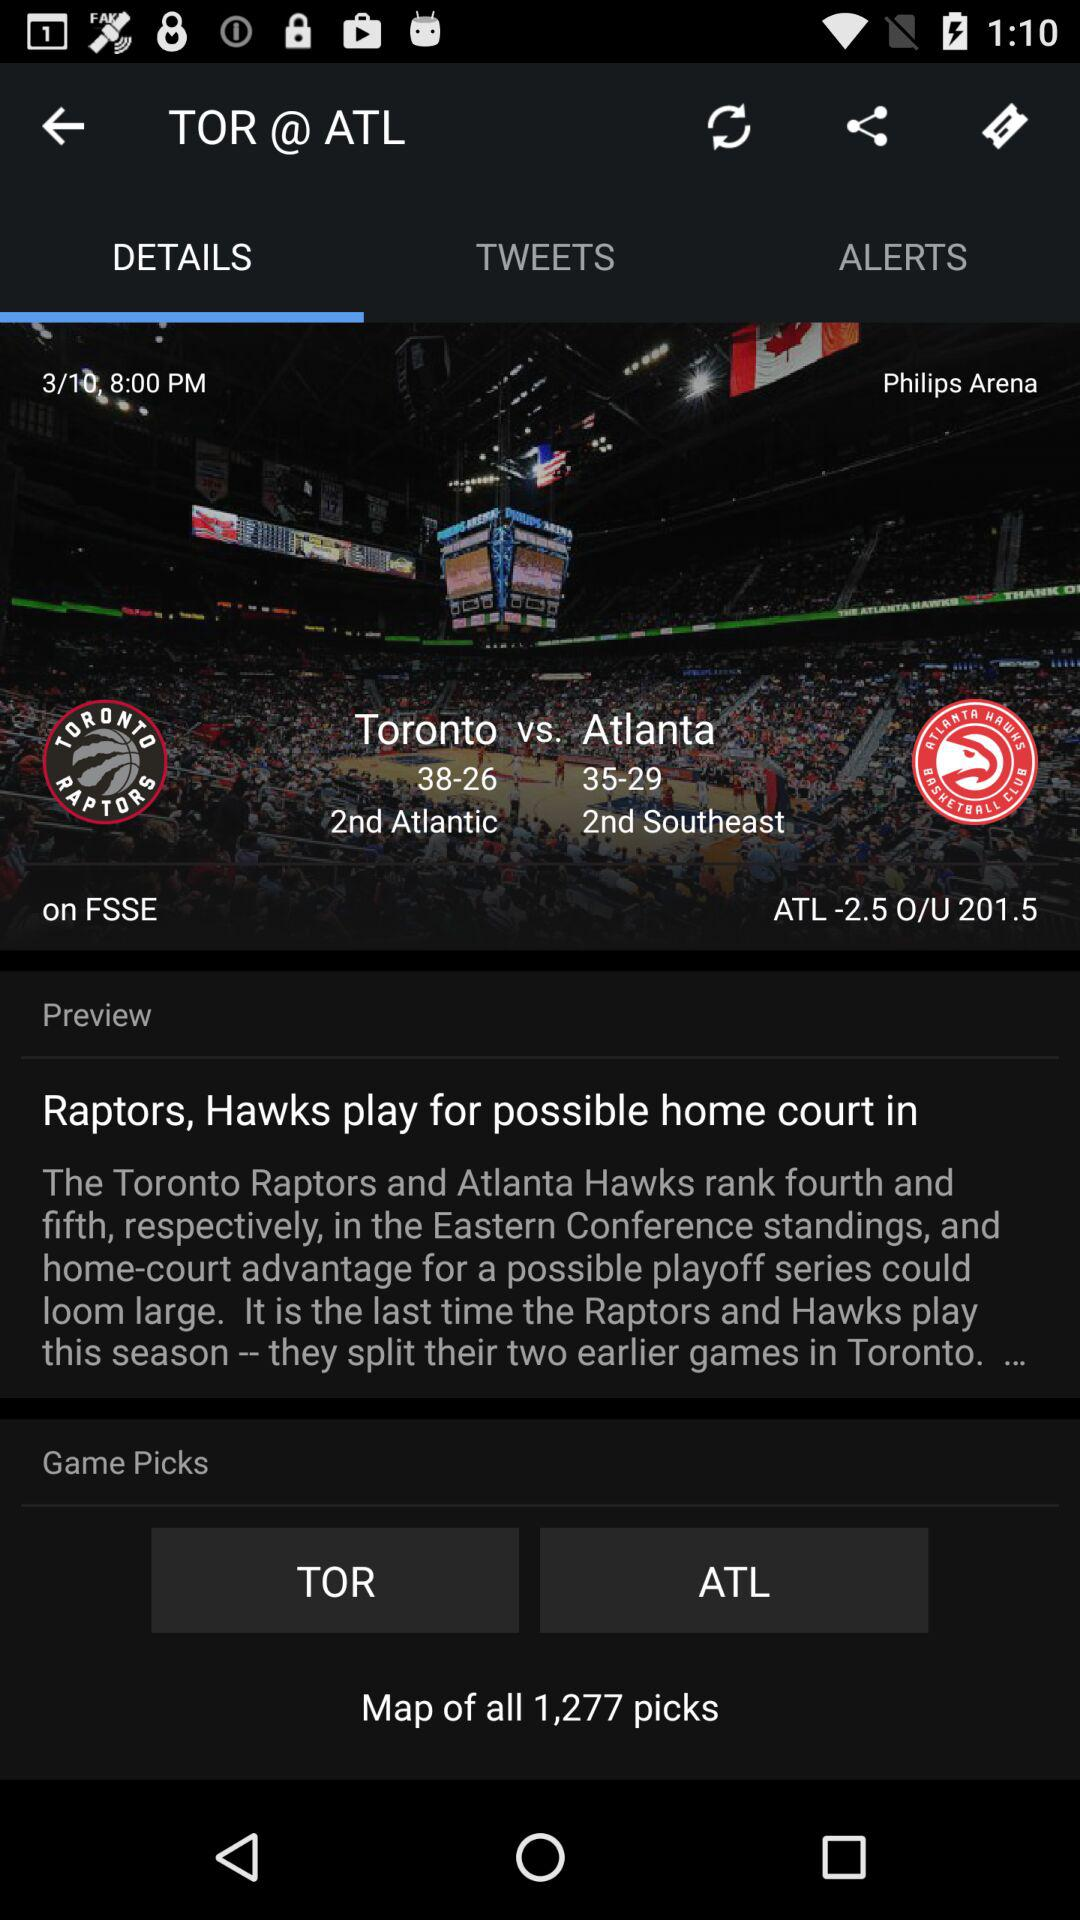On what date and time was the match played? The match was played on March 10 at 8:00 p.m. 